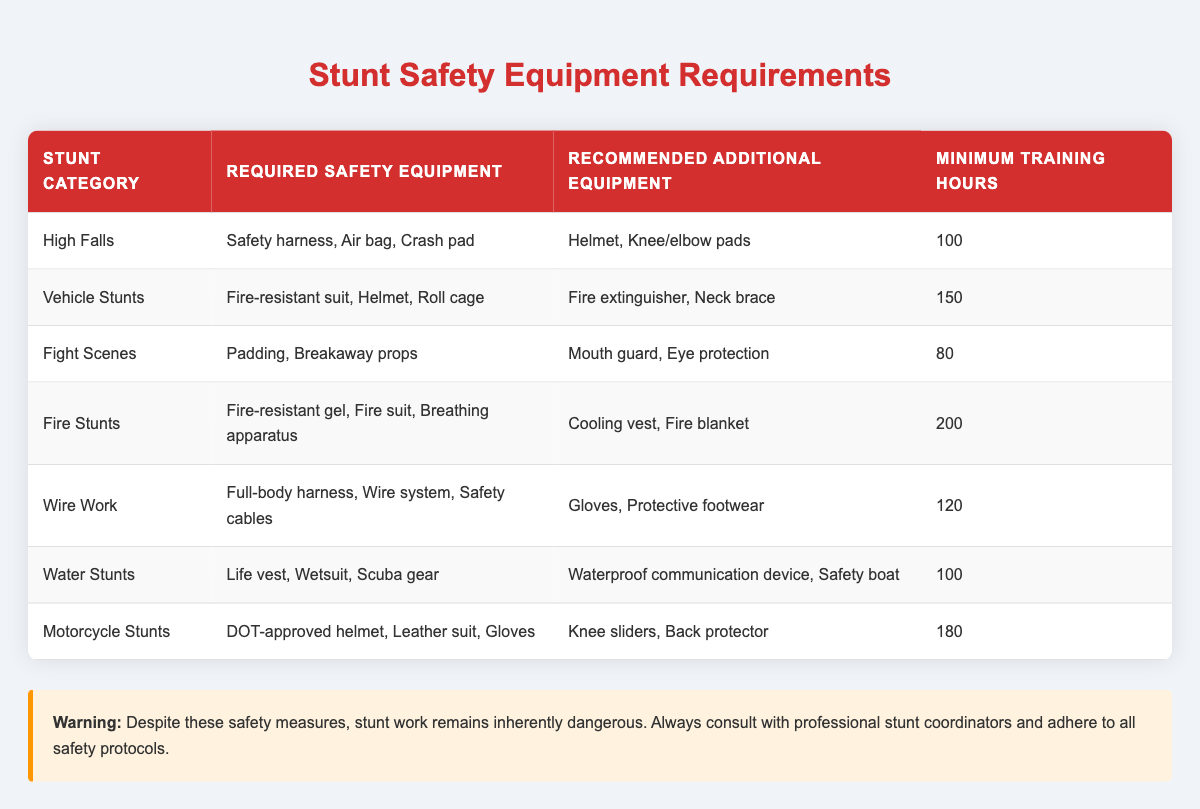What safety equipment is required for Vehicle Stunts? According to the table, the required safety equipment for Vehicle Stunts includes a fire-resistant suit, helmet, and roll cage.
Answer: Fire-resistant suit, helmet, roll cage How many minimum training hours are required for Fire Stunts? The table specifies that the minimum training hours required for Fire Stunts is 200.
Answer: 200 Is a mouth guard recommended for all types of stunts? A mouth guard is only listed as recommended additional equipment for Fight Scenes, meaning it is not universally recommended for all stunt categories.
Answer: No Which stunt category requires the least amount of training hours? By comparing the training hours listed for each category, Fight Scenes require the least amount of training hours at 80.
Answer: Fight Scenes What is the difference in minimum training hours between High Falls and Motorcycle Stunts? The minimum training hours for High Falls is 100 and for Motorcycle Stunts is 180. The difference is calculated as 180 - 100 = 80 hours.
Answer: 80 Which stunt category requires both a fire suit and a breathing apparatus? The table indicates that Fire Stunts require both a fire-resistant gel and a fire suit, as well as a breathing apparatus.
Answer: Fire Stunts Do all stunt categories require a helmet? The table shows that helmets are required for High Falls, Vehicle Stunts, Fight Scenes, and Motorcycle Stunts, while Water Stunts and Fire Stunts do not list helmet as required equipment.
Answer: No What additional equipment is recommended for Wire Work? The table specifies that the recommended additional equipment for Wire Work includes gloves and protective footwear.
Answer: Gloves, protective footwear Which stunt category requires the longest training hours, and what is that duration? The table reveals that Fire Stunts require the longest training hours, totaling 200 hours.
Answer: 200 What is the combined total of minimum training hours for Water Stunts and Fight Scenes? Water Stunts require 100 hours and Fight Scenes require 80 hours. The combined total is 100 + 80 = 180 hours.
Answer: 180 